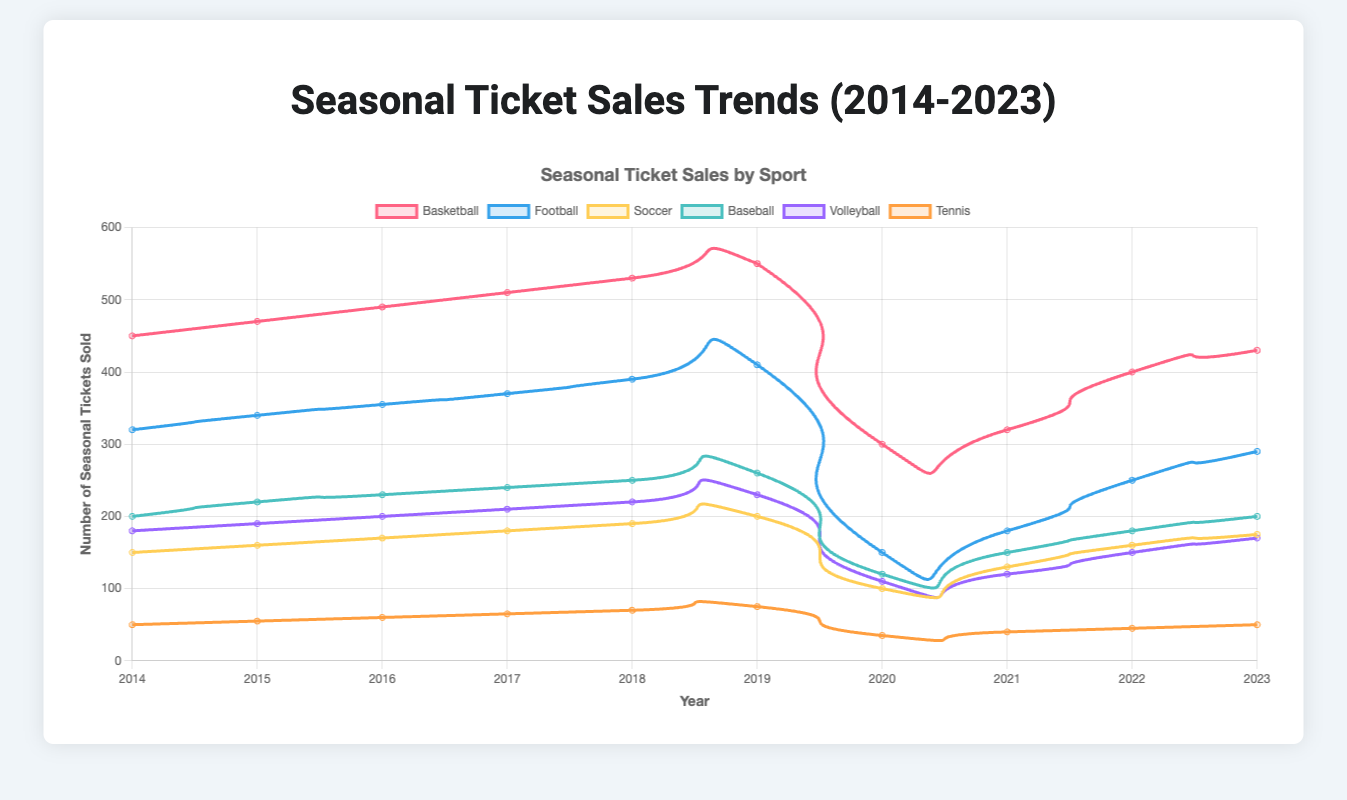what is the total number of basketball tickets sold over the 10-year period? Sum up the number of basketball tickets sold each year: 450 + 470 + 490 + 510 + 530 + 550 + 300 + 320 + 400 + 430. This results in 4450 tickets.
Answer: 4450 which sport had the highest ticket sales in 2019? Referring to the year 2019, compare the ticket sales of all sports: Basketball (550), Football (410), Soccer (200), Baseball (260), Volleyball (230), Tennis (75). Basketball has the highest sales.
Answer: Basketball how did football ticket sales change from 2018 to 2020? Football sales in 2018 were 390 and in 2020 were 150. To find the change, subtract 150 from 390, resulting in a decrease of 240 tickets.
Answer: Decreased by 240 which sport showed the smallest increase in ticket sales from 2014 to 2023? Calculate the increase for each sport from 2014 to 2023:
- Basketball: 430 - 450 = -20
- Football: 290 - 320 = -30
- Soccer: 175 - 150 = 25
- Baseball: 200 - 200 = 0
- Volleyball: 170 - 180 = -10
- Tennis: 50 - 50 = 0.
Smallest increase (actually a no increase) in ticket sales is for Baseball and Tennis, both at 0.
Answer: Baseball and Tennis what is the average ticket sales for volleyball over the 10 years? Sum the volleyball ticket sales: 180 + 190 + 200 + 210 + 220 + 230 + 110 + 120 + 150 + 170 = 1780. Then, divide by 10: 1780/10 = 178.
Answer: 178 did soccer ticket sales trend upward or downward from 2014 to 2023? Starting at 150 in 2014 and moving to 175 by 2023, the trend shows an upward trajectory.
Answer: Upward which two sports witnessed the biggest drop in sales between 2019 and 2020? Compare 2019 and 2020 for each sport:
- Basketball: 550 to 300 (250 drop)
- Football: 410 to 150 (260 drop)
- Soccer: 200 to 100 (100 drop)
- Baseball: 260 to 120 (140 drop)
- Volleyball: 230 to 110 (120 drop)
- Tennis: 75 to 35 (40 drop).
Football and Basketball witnessed the biggest drops.
Answer: Football and Basketball what conclusion can be drawn about tennis sales over the 10-year period? Tennis sales show consistent small growth: from 50 in 2014 to 50 in 2023, with some variations, the overall trend is nearly stable.
Answer: Stable in which year did basketball see the biggest drop in ticket sales? Basketball sales dropped 2020 to 300 from 550 in 2019, the largest drop by 250 tickets between two consecutive years.
Answer: 2020 what is the trend in ticket sales for volleyball from 2020 to 2023? From 2020, volleyball ticket sales increased from 110 to 120 in 2021, and then rose to 150 in 2022, finishing at 170 in 2023. The trend is upward.
Answer: Upward 